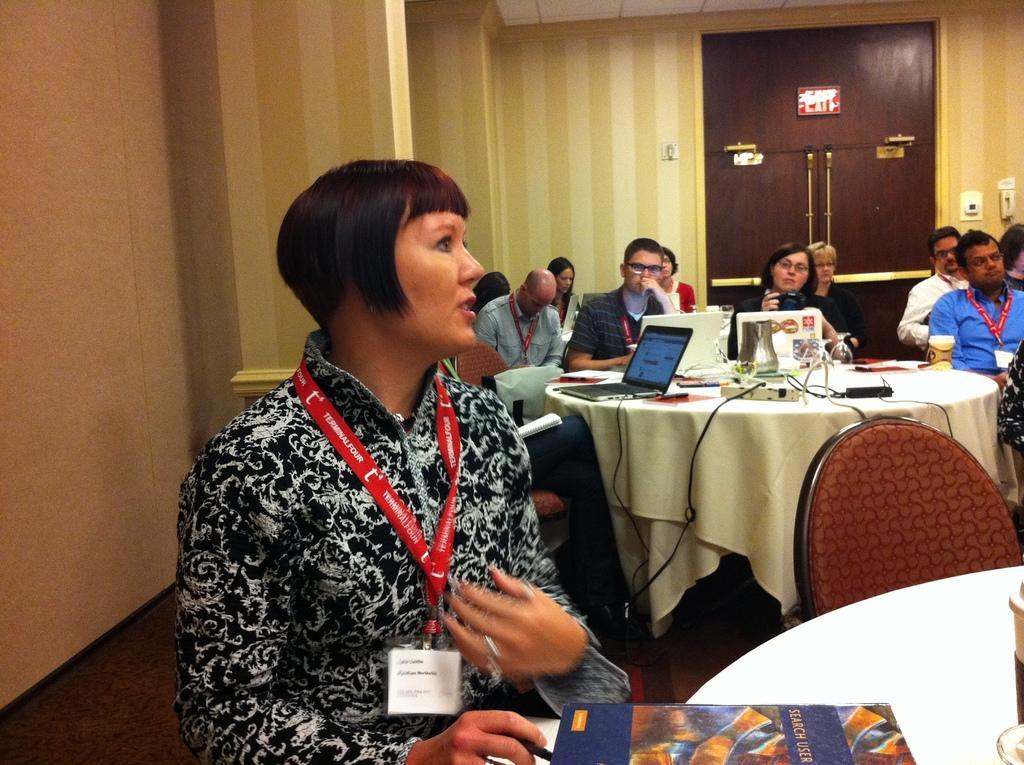Please provide a concise description of this image. In this picture some people are sitting on the chair in front of the table and the table contains laptop,wire board,books,charger and the background is yellow. 